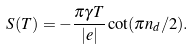Convert formula to latex. <formula><loc_0><loc_0><loc_500><loc_500>S ( T ) = - \frac { \pi \gamma T } { | e | } \cot ( \pi n _ { d } / 2 ) .</formula> 